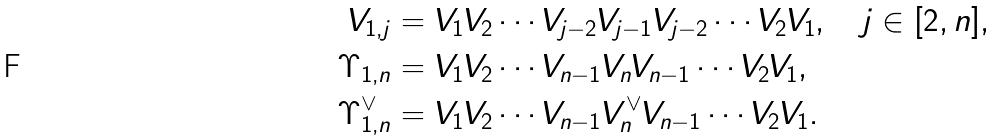Convert formula to latex. <formula><loc_0><loc_0><loc_500><loc_500>V _ { 1 , j } & = V _ { 1 } V _ { 2 } \cdots V _ { j - 2 } V _ { j - 1 } V _ { j - 2 } \cdots V _ { 2 } V _ { 1 } , \quad j \in [ 2 , n ] , \\ \Upsilon _ { 1 , n } & = V _ { 1 } V _ { 2 } \cdots V _ { n - 1 } V _ { n } V _ { n - 1 } \cdots V _ { 2 } V _ { 1 } , \\ \Upsilon _ { 1 , n } ^ { \vee } & = V _ { 1 } V _ { 2 } \cdots V _ { n - 1 } V _ { n } ^ { \vee } V _ { n - 1 } \cdots V _ { 2 } V _ { 1 } .</formula> 